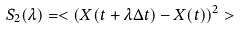Convert formula to latex. <formula><loc_0><loc_0><loc_500><loc_500>S _ { 2 } ( \lambda ) = < ( X ( t + \lambda \Delta t ) - X ( t ) ) ^ { 2 } ></formula> 